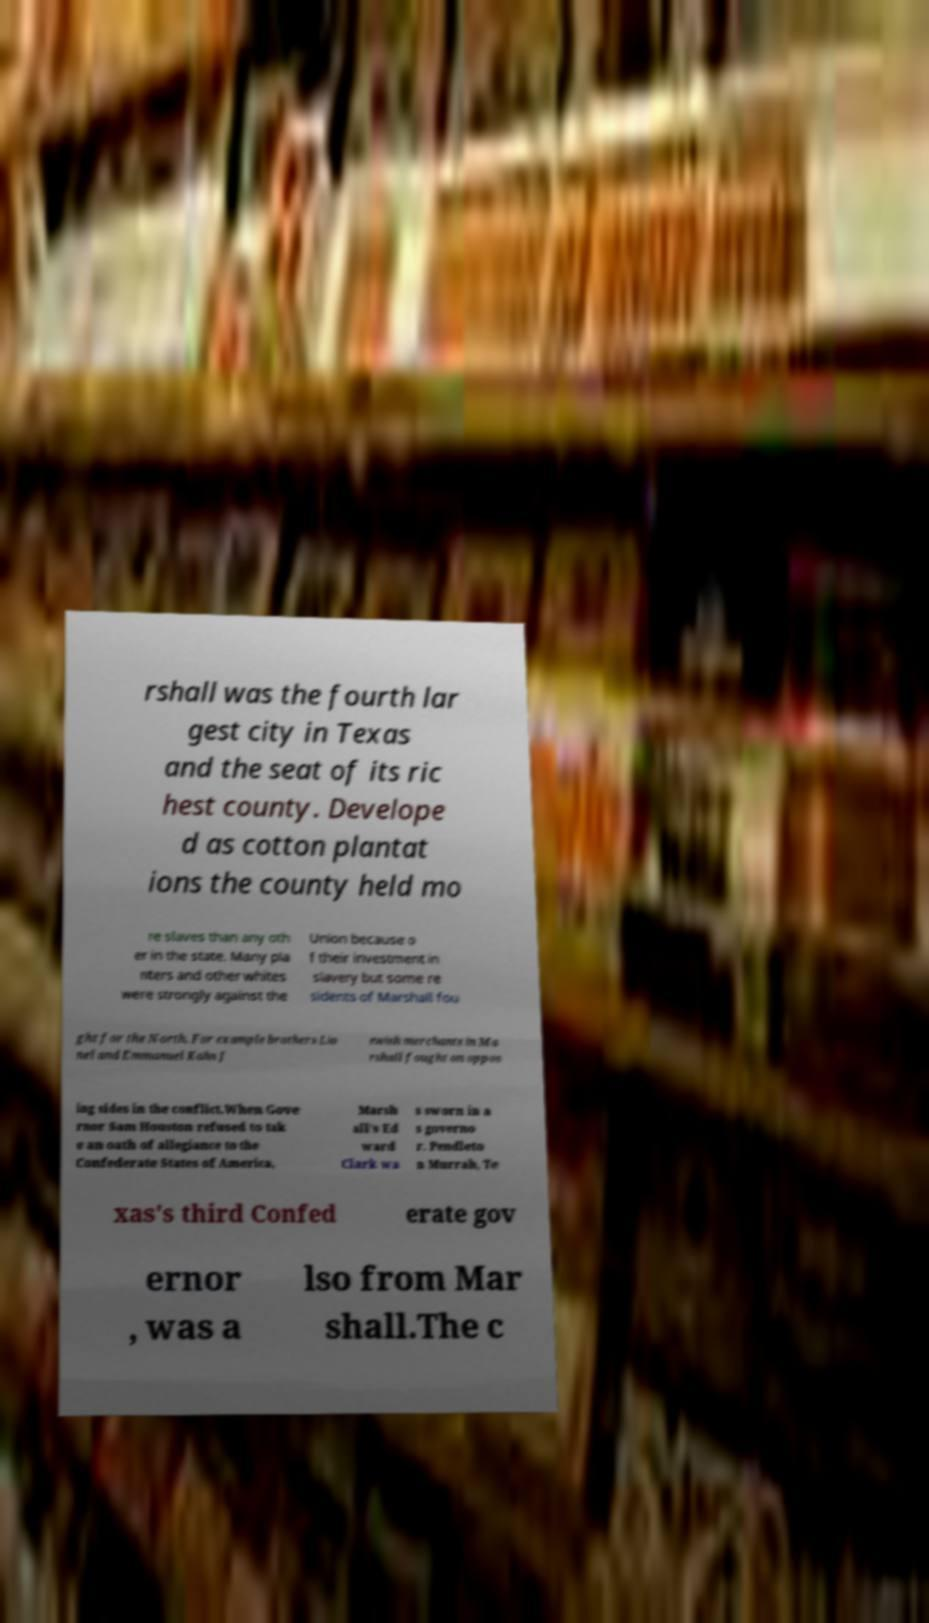There's text embedded in this image that I need extracted. Can you transcribe it verbatim? rshall was the fourth lar gest city in Texas and the seat of its ric hest county. Develope d as cotton plantat ions the county held mo re slaves than any oth er in the state. Many pla nters and other whites were strongly against the Union because o f their investment in slavery but some re sidents of Marshall fou ght for the North. For example brothers Lio nel and Emmanuel Kahn J ewish merchants in Ma rshall fought on oppos ing sides in the conflict.When Gove rnor Sam Houston refused to tak e an oath of allegiance to the Confederate States of America, Marsh all's Ed ward Clark wa s sworn in a s governo r. Pendleto n Murrah, Te xas's third Confed erate gov ernor , was a lso from Mar shall.The c 